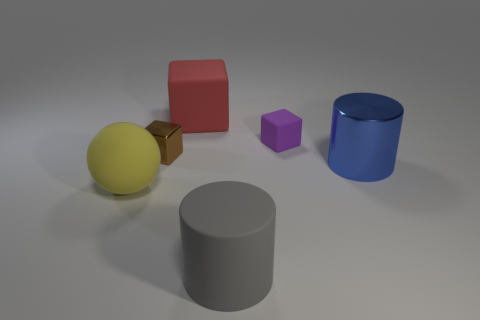Subtract all tiny matte blocks. How many blocks are left? 2 Subtract all brown blocks. How many blocks are left? 2 Subtract all spheres. How many objects are left? 5 Subtract 1 cubes. How many cubes are left? 2 Add 1 metal blocks. How many metal blocks exist? 2 Add 1 rubber cylinders. How many objects exist? 7 Subtract 1 gray cylinders. How many objects are left? 5 Subtract all purple cubes. Subtract all brown cylinders. How many cubes are left? 2 Subtract all blue objects. Subtract all large red matte blocks. How many objects are left? 4 Add 5 tiny brown things. How many tiny brown things are left? 6 